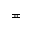Convert formula to latex. <formula><loc_0><loc_0><loc_500><loc_500>\ e q c i r c</formula> 